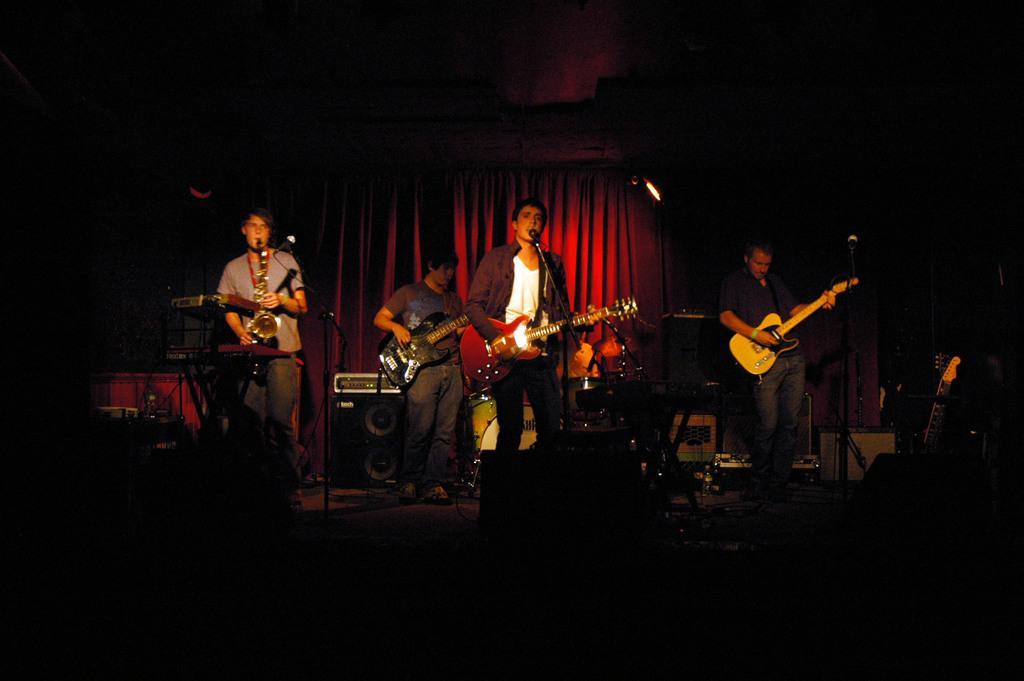How would you summarize this image in a sentence or two? In this image I see 4 men, in which these 3 are holding the guitars and this man is holding a musical instrument and I see the mics. In the background I see the speakers, drums and a person and the curtain. 